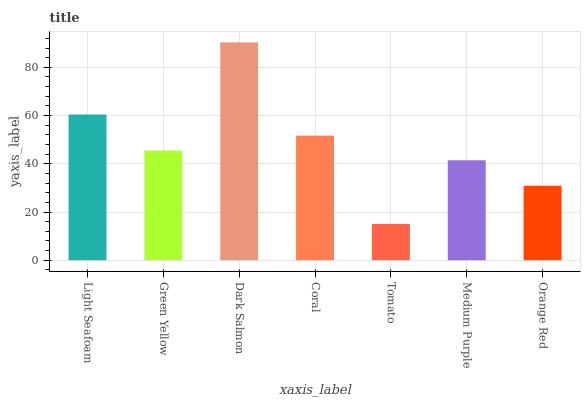Is Tomato the minimum?
Answer yes or no. Yes. Is Dark Salmon the maximum?
Answer yes or no. Yes. Is Green Yellow the minimum?
Answer yes or no. No. Is Green Yellow the maximum?
Answer yes or no. No. Is Light Seafoam greater than Green Yellow?
Answer yes or no. Yes. Is Green Yellow less than Light Seafoam?
Answer yes or no. Yes. Is Green Yellow greater than Light Seafoam?
Answer yes or no. No. Is Light Seafoam less than Green Yellow?
Answer yes or no. No. Is Green Yellow the high median?
Answer yes or no. Yes. Is Green Yellow the low median?
Answer yes or no. Yes. Is Coral the high median?
Answer yes or no. No. Is Tomato the low median?
Answer yes or no. No. 